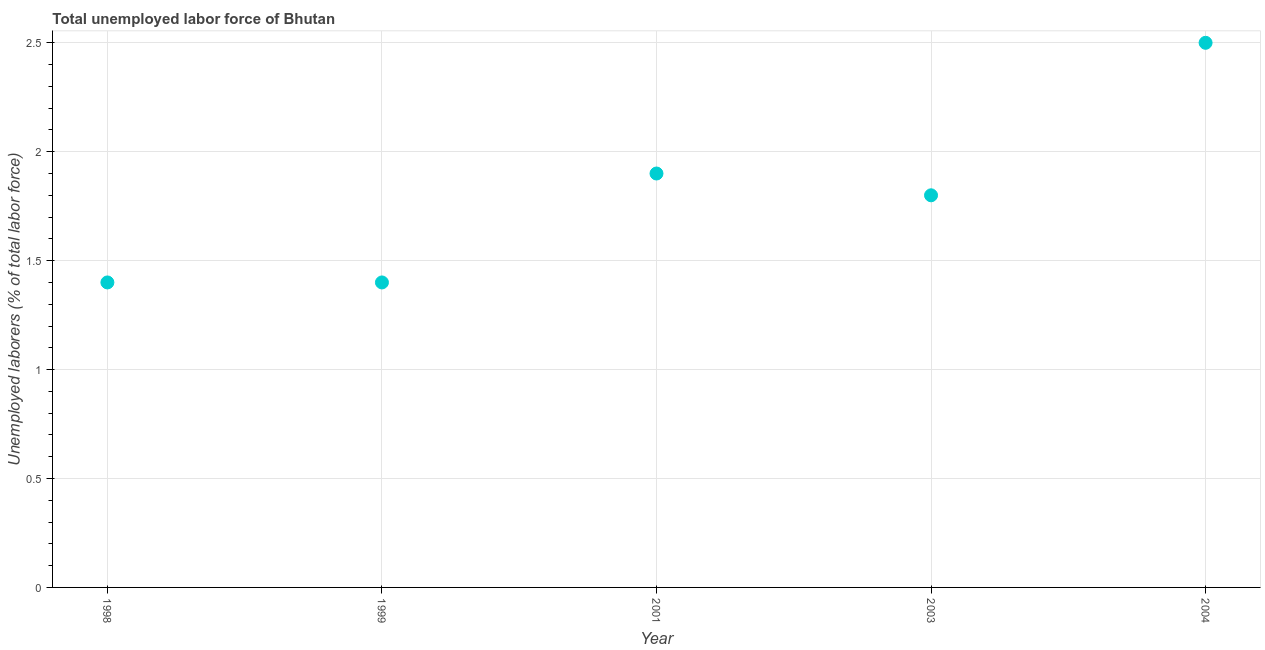What is the total unemployed labour force in 1998?
Offer a terse response. 1.4. Across all years, what is the maximum total unemployed labour force?
Your answer should be very brief. 2.5. Across all years, what is the minimum total unemployed labour force?
Offer a terse response. 1.4. In which year was the total unemployed labour force maximum?
Provide a short and direct response. 2004. In which year was the total unemployed labour force minimum?
Provide a succinct answer. 1998. What is the sum of the total unemployed labour force?
Make the answer very short. 9. What is the difference between the total unemployed labour force in 2001 and 2004?
Provide a short and direct response. -0.6. What is the average total unemployed labour force per year?
Keep it short and to the point. 1.8. What is the median total unemployed labour force?
Your answer should be very brief. 1.8. Do a majority of the years between 2003 and 1998 (inclusive) have total unemployed labour force greater than 1.8 %?
Give a very brief answer. Yes. What is the ratio of the total unemployed labour force in 1999 to that in 2001?
Provide a succinct answer. 0.74. Is the difference between the total unemployed labour force in 1999 and 2004 greater than the difference between any two years?
Provide a short and direct response. Yes. What is the difference between the highest and the second highest total unemployed labour force?
Your answer should be very brief. 0.6. Is the sum of the total unemployed labour force in 1998 and 2003 greater than the maximum total unemployed labour force across all years?
Your response must be concise. Yes. What is the difference between the highest and the lowest total unemployed labour force?
Ensure brevity in your answer.  1.1. In how many years, is the total unemployed labour force greater than the average total unemployed labour force taken over all years?
Provide a short and direct response. 2. How many dotlines are there?
Your answer should be very brief. 1. What is the difference between two consecutive major ticks on the Y-axis?
Offer a terse response. 0.5. Are the values on the major ticks of Y-axis written in scientific E-notation?
Your answer should be compact. No. What is the title of the graph?
Make the answer very short. Total unemployed labor force of Bhutan. What is the label or title of the Y-axis?
Give a very brief answer. Unemployed laborers (% of total labor force). What is the Unemployed laborers (% of total labor force) in 1998?
Give a very brief answer. 1.4. What is the Unemployed laborers (% of total labor force) in 1999?
Your answer should be compact. 1.4. What is the Unemployed laborers (% of total labor force) in 2001?
Your answer should be very brief. 1.9. What is the Unemployed laborers (% of total labor force) in 2003?
Offer a very short reply. 1.8. What is the difference between the Unemployed laborers (% of total labor force) in 1998 and 1999?
Keep it short and to the point. 0. What is the difference between the Unemployed laborers (% of total labor force) in 1998 and 2001?
Provide a short and direct response. -0.5. What is the difference between the Unemployed laborers (% of total labor force) in 1998 and 2003?
Ensure brevity in your answer.  -0.4. What is the difference between the Unemployed laborers (% of total labor force) in 1999 and 2001?
Keep it short and to the point. -0.5. What is the difference between the Unemployed laborers (% of total labor force) in 1999 and 2003?
Ensure brevity in your answer.  -0.4. What is the difference between the Unemployed laborers (% of total labor force) in 1999 and 2004?
Provide a succinct answer. -1.1. What is the difference between the Unemployed laborers (% of total labor force) in 2001 and 2003?
Provide a short and direct response. 0.1. What is the difference between the Unemployed laborers (% of total labor force) in 2003 and 2004?
Give a very brief answer. -0.7. What is the ratio of the Unemployed laborers (% of total labor force) in 1998 to that in 2001?
Your answer should be compact. 0.74. What is the ratio of the Unemployed laborers (% of total labor force) in 1998 to that in 2003?
Give a very brief answer. 0.78. What is the ratio of the Unemployed laborers (% of total labor force) in 1998 to that in 2004?
Offer a terse response. 0.56. What is the ratio of the Unemployed laborers (% of total labor force) in 1999 to that in 2001?
Your response must be concise. 0.74. What is the ratio of the Unemployed laborers (% of total labor force) in 1999 to that in 2003?
Give a very brief answer. 0.78. What is the ratio of the Unemployed laborers (% of total labor force) in 1999 to that in 2004?
Offer a terse response. 0.56. What is the ratio of the Unemployed laborers (% of total labor force) in 2001 to that in 2003?
Provide a short and direct response. 1.06. What is the ratio of the Unemployed laborers (% of total labor force) in 2001 to that in 2004?
Offer a very short reply. 0.76. What is the ratio of the Unemployed laborers (% of total labor force) in 2003 to that in 2004?
Give a very brief answer. 0.72. 